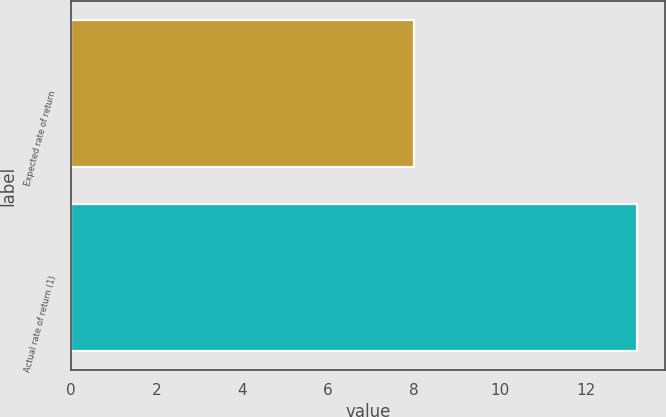<chart> <loc_0><loc_0><loc_500><loc_500><bar_chart><fcel>Expected rate of return<fcel>Actual rate of return (1)<nl><fcel>8<fcel>13.2<nl></chart> 